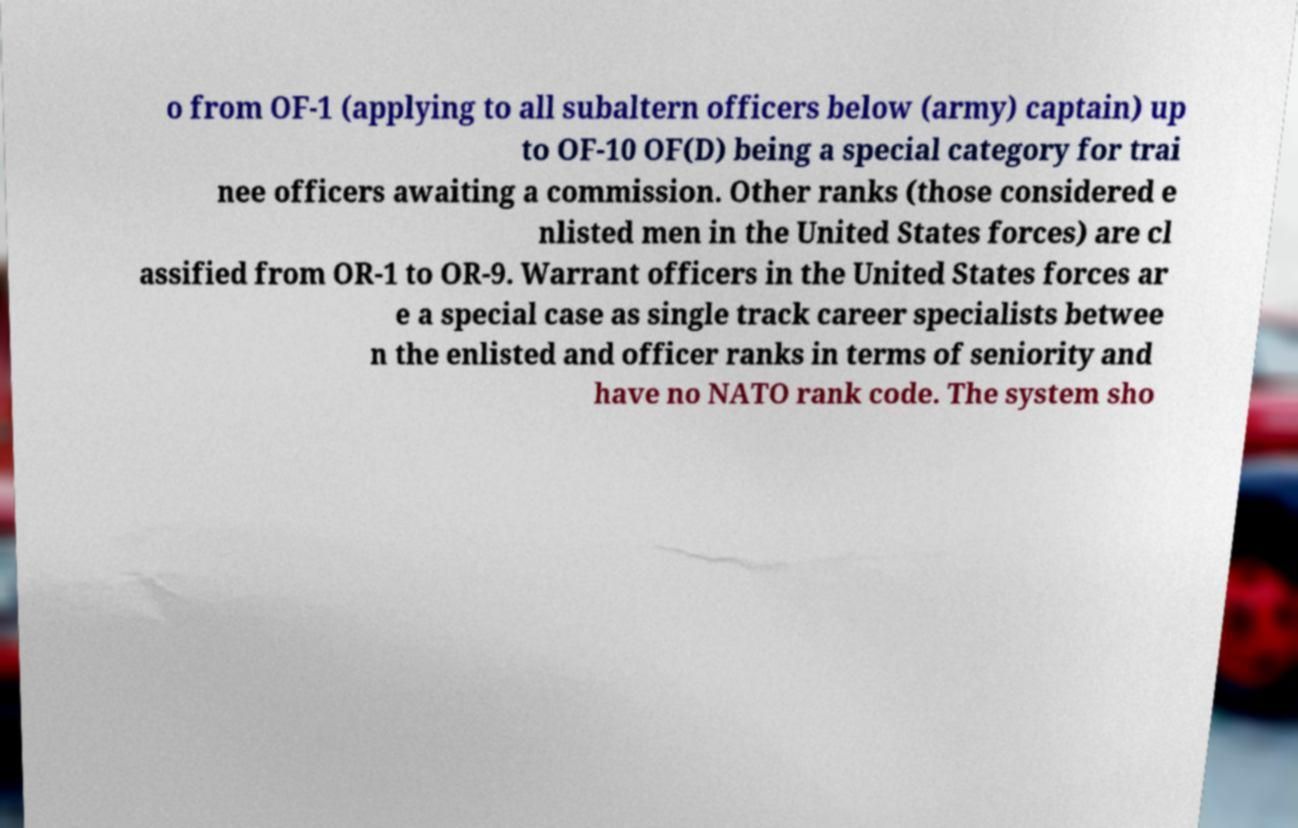Please read and relay the text visible in this image. What does it say? o from OF-1 (applying to all subaltern officers below (army) captain) up to OF-10 OF(D) being a special category for trai nee officers awaiting a commission. Other ranks (those considered e nlisted men in the United States forces) are cl assified from OR-1 to OR-9. Warrant officers in the United States forces ar e a special case as single track career specialists betwee n the enlisted and officer ranks in terms of seniority and have no NATO rank code. The system sho 